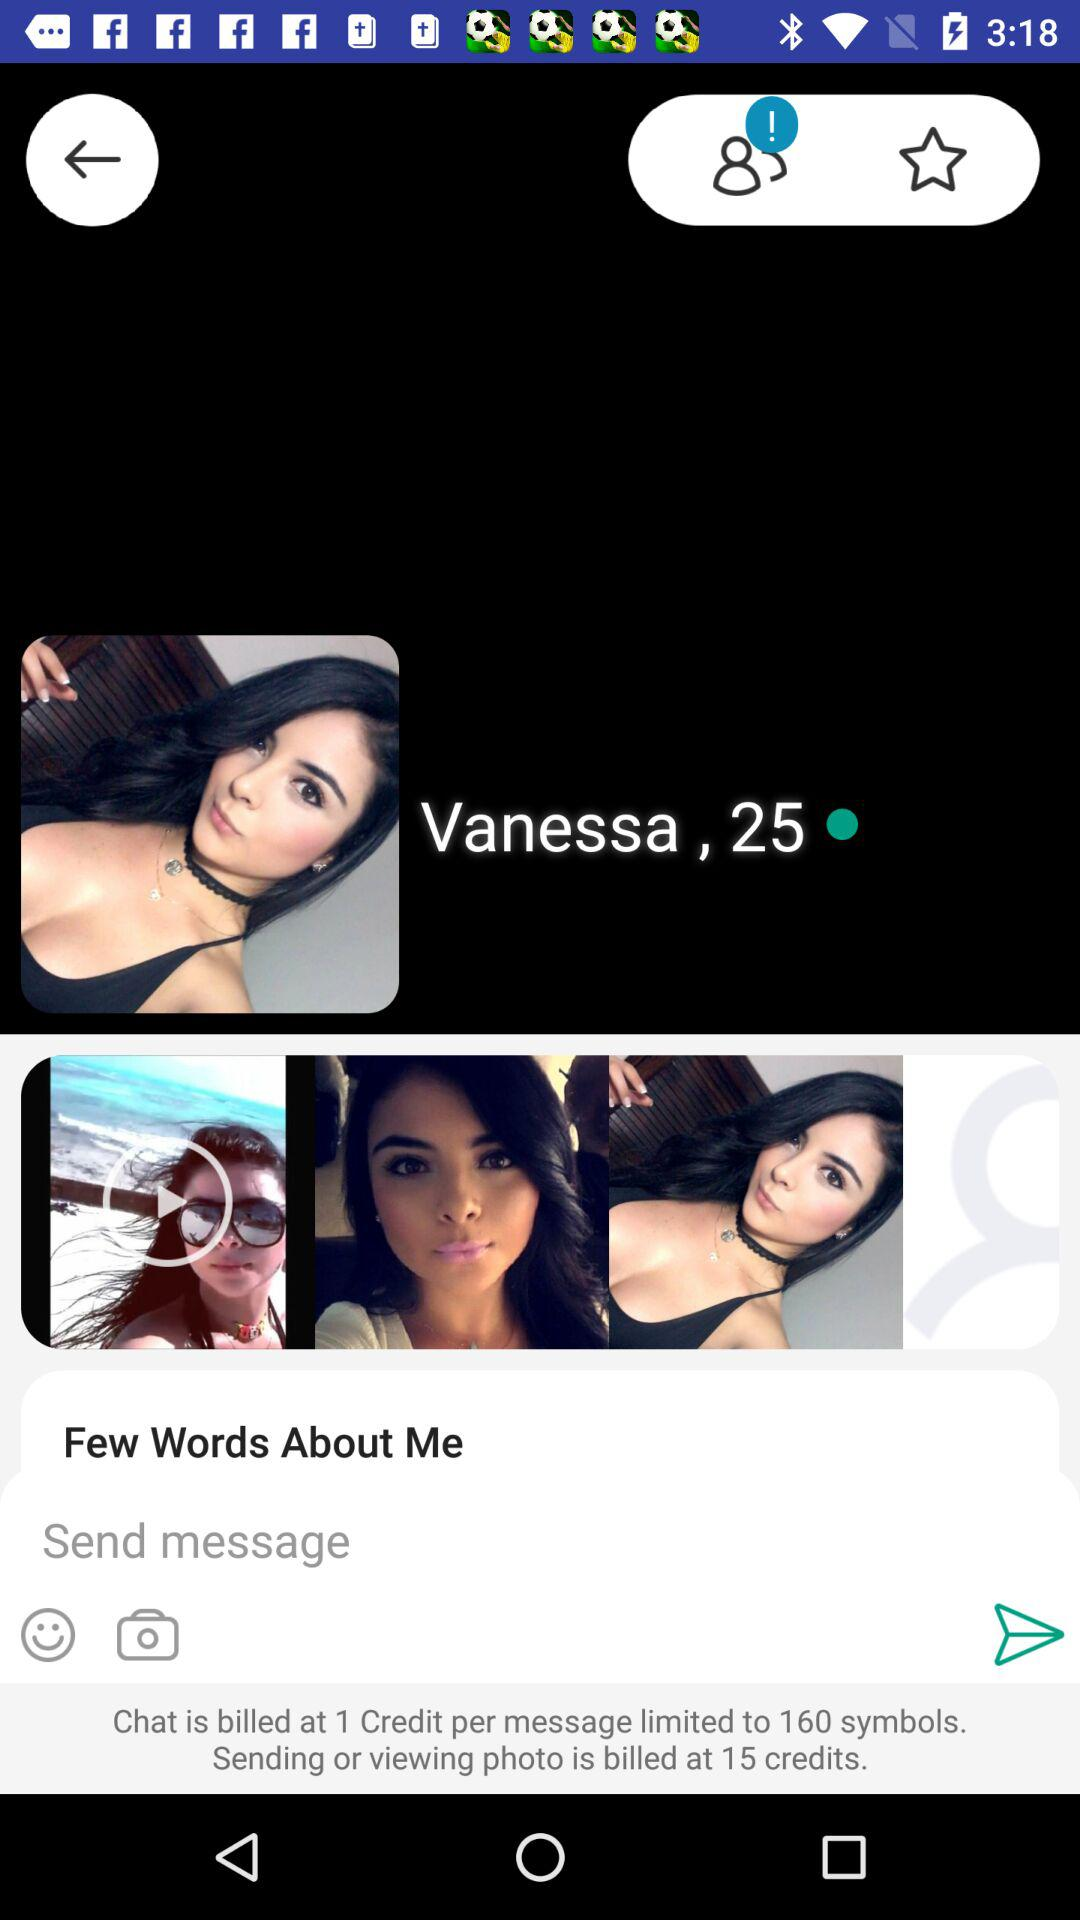What is the age of the user? The ager of the user is 25. 